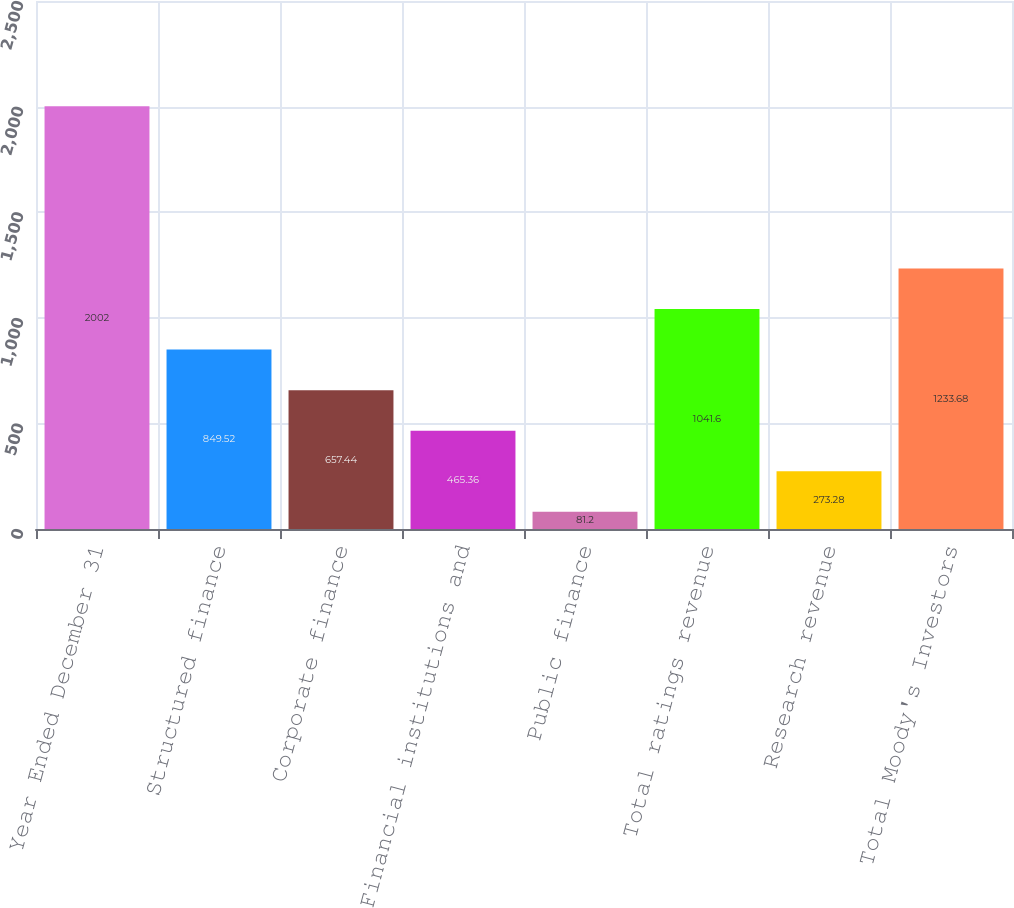Convert chart to OTSL. <chart><loc_0><loc_0><loc_500><loc_500><bar_chart><fcel>Year Ended December 31<fcel>Structured finance<fcel>Corporate finance<fcel>Financial institutions and<fcel>Public finance<fcel>Total ratings revenue<fcel>Research revenue<fcel>Total Moody's Investors<nl><fcel>2002<fcel>849.52<fcel>657.44<fcel>465.36<fcel>81.2<fcel>1041.6<fcel>273.28<fcel>1233.68<nl></chart> 